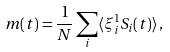Convert formula to latex. <formula><loc_0><loc_0><loc_500><loc_500>m ( t ) = \frac { 1 } { N } \sum _ { i } \langle \xi _ { i } ^ { 1 } S _ { i } ( t ) \rangle \, ,</formula> 